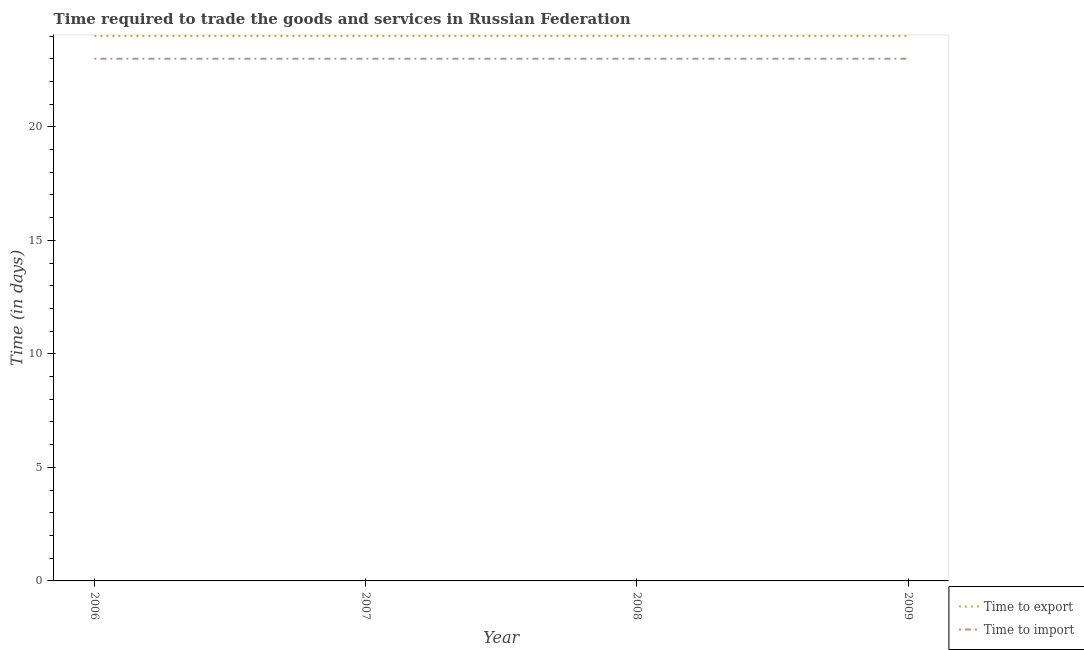How many different coloured lines are there?
Offer a terse response. 2. Does the line corresponding to time to import intersect with the line corresponding to time to export?
Your answer should be very brief. No. Across all years, what is the minimum time to import?
Provide a succinct answer. 23. In which year was the time to export maximum?
Your answer should be very brief. 2006. What is the total time to import in the graph?
Provide a short and direct response. 92. What is the difference between the time to export in 2007 and that in 2009?
Offer a terse response. 0. In the year 2009, what is the difference between the time to export and time to import?
Offer a terse response. 1. What is the ratio of the time to import in 2007 to that in 2009?
Your answer should be very brief. 1. Is the difference between the time to import in 2007 and 2008 greater than the difference between the time to export in 2007 and 2008?
Your response must be concise. No. What is the difference between the highest and the lowest time to export?
Make the answer very short. 0. Is the time to import strictly greater than the time to export over the years?
Your answer should be very brief. No. How many years are there in the graph?
Your response must be concise. 4. What is the difference between two consecutive major ticks on the Y-axis?
Your answer should be very brief. 5. Does the graph contain grids?
Offer a very short reply. No. Where does the legend appear in the graph?
Give a very brief answer. Bottom right. How many legend labels are there?
Provide a short and direct response. 2. How are the legend labels stacked?
Make the answer very short. Vertical. What is the title of the graph?
Keep it short and to the point. Time required to trade the goods and services in Russian Federation. Does "Domestic liabilities" appear as one of the legend labels in the graph?
Your response must be concise. No. What is the label or title of the X-axis?
Offer a terse response. Year. What is the label or title of the Y-axis?
Ensure brevity in your answer.  Time (in days). What is the Time (in days) in Time to export in 2006?
Offer a very short reply. 24. What is the Time (in days) in Time to import in 2007?
Provide a short and direct response. 23. What is the Time (in days) in Time to export in 2008?
Make the answer very short. 24. What is the Time (in days) in Time to import in 2008?
Give a very brief answer. 23. What is the Time (in days) of Time to import in 2009?
Keep it short and to the point. 23. Across all years, what is the maximum Time (in days) of Time to import?
Make the answer very short. 23. What is the total Time (in days) in Time to export in the graph?
Offer a terse response. 96. What is the total Time (in days) of Time to import in the graph?
Keep it short and to the point. 92. What is the difference between the Time (in days) of Time to export in 2006 and that in 2008?
Offer a very short reply. 0. What is the difference between the Time (in days) in Time to import in 2007 and that in 2008?
Your answer should be compact. 0. What is the difference between the Time (in days) of Time to export in 2008 and that in 2009?
Keep it short and to the point. 0. What is the difference between the Time (in days) in Time to import in 2008 and that in 2009?
Provide a succinct answer. 0. What is the difference between the Time (in days) in Time to export in 2006 and the Time (in days) in Time to import in 2007?
Offer a very short reply. 1. What is the difference between the Time (in days) in Time to export in 2006 and the Time (in days) in Time to import in 2009?
Offer a terse response. 1. What is the difference between the Time (in days) of Time to export in 2008 and the Time (in days) of Time to import in 2009?
Offer a very short reply. 1. What is the average Time (in days) of Time to export per year?
Keep it short and to the point. 24. What is the average Time (in days) in Time to import per year?
Make the answer very short. 23. In the year 2009, what is the difference between the Time (in days) in Time to export and Time (in days) in Time to import?
Provide a short and direct response. 1. What is the ratio of the Time (in days) of Time to export in 2006 to that in 2007?
Offer a terse response. 1. What is the ratio of the Time (in days) in Time to import in 2006 to that in 2007?
Your response must be concise. 1. What is the ratio of the Time (in days) of Time to import in 2006 to that in 2008?
Provide a succinct answer. 1. What is the ratio of the Time (in days) of Time to export in 2006 to that in 2009?
Give a very brief answer. 1. What is the ratio of the Time (in days) of Time to export in 2007 to that in 2008?
Provide a short and direct response. 1. What is the ratio of the Time (in days) of Time to import in 2007 to that in 2008?
Provide a succinct answer. 1. What is the ratio of the Time (in days) of Time to export in 2008 to that in 2009?
Provide a succinct answer. 1. What is the difference between the highest and the second highest Time (in days) in Time to export?
Offer a very short reply. 0. What is the difference between the highest and the lowest Time (in days) of Time to export?
Provide a short and direct response. 0. 